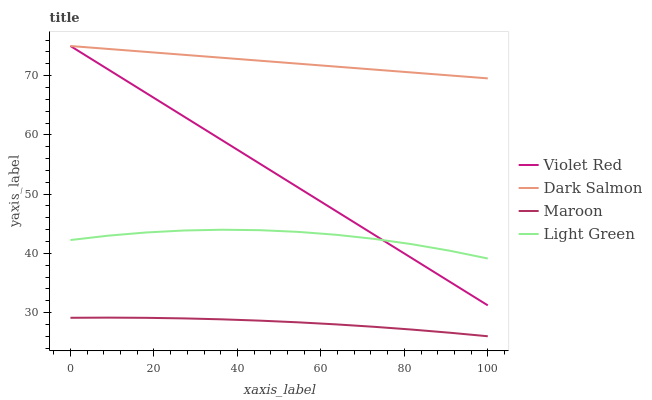Does Maroon have the minimum area under the curve?
Answer yes or no. Yes. Does Dark Salmon have the maximum area under the curve?
Answer yes or no. Yes. Does Light Green have the minimum area under the curve?
Answer yes or no. No. Does Light Green have the maximum area under the curve?
Answer yes or no. No. Is Violet Red the smoothest?
Answer yes or no. Yes. Is Light Green the roughest?
Answer yes or no. Yes. Is Dark Salmon the smoothest?
Answer yes or no. No. Is Dark Salmon the roughest?
Answer yes or no. No. Does Maroon have the lowest value?
Answer yes or no. Yes. Does Light Green have the lowest value?
Answer yes or no. No. Does Dark Salmon have the highest value?
Answer yes or no. Yes. Does Light Green have the highest value?
Answer yes or no. No. Is Light Green less than Dark Salmon?
Answer yes or no. Yes. Is Violet Red greater than Maroon?
Answer yes or no. Yes. Does Light Green intersect Violet Red?
Answer yes or no. Yes. Is Light Green less than Violet Red?
Answer yes or no. No. Is Light Green greater than Violet Red?
Answer yes or no. No. Does Light Green intersect Dark Salmon?
Answer yes or no. No. 